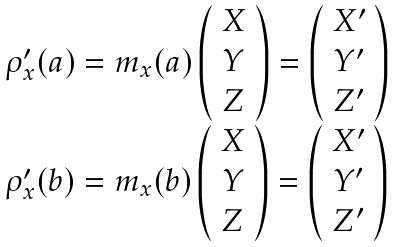Convert formula to latex. <formula><loc_0><loc_0><loc_500><loc_500>\begin{array} { l } \rho _ { x } ^ { \prime } ( a ) = m _ { x } ( a ) \left ( \begin{array} { c } X \\ Y \\ Z \end{array} \right ) = \left ( \begin{array} { c } X ^ { \prime } \\ Y ^ { \prime } \\ Z ^ { \prime } \end{array} \right ) \\ \rho _ { x } ^ { \prime } ( b ) = m _ { x } ( b ) \left ( \begin{array} { c } X \\ Y \\ Z \end{array} \right ) = \left ( \begin{array} { c } X ^ { \prime } \\ Y ^ { \prime } \\ Z ^ { \prime } \end{array} \right ) \end{array}</formula> 